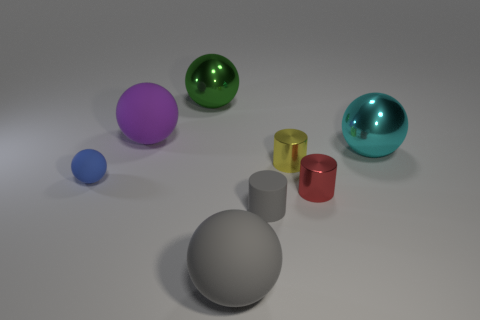How many other objects are there of the same size as the blue rubber object?
Provide a succinct answer. 3. There is a metal cylinder behind the blue rubber sphere; what is its color?
Your response must be concise. Yellow. Are the large sphere right of the red cylinder and the large gray ball made of the same material?
Offer a terse response. No. How many metallic things are to the left of the large cyan sphere and on the right side of the large gray rubber object?
Provide a succinct answer. 2. The large rubber sphere in front of the large matte ball that is on the left side of the big metallic object that is to the left of the big cyan metallic object is what color?
Your answer should be very brief. Gray. How many other things are the same shape as the red thing?
Your answer should be compact. 2. There is a gray thing that is on the right side of the large gray thing; are there any yellow shiny cylinders on the left side of it?
Give a very brief answer. No. How many metal things are tiny red cubes or big objects?
Give a very brief answer. 2. There is a sphere that is both behind the big gray rubber object and in front of the cyan thing; what material is it made of?
Make the answer very short. Rubber. There is a small thing that is on the left side of the big metallic object that is behind the purple matte ball; are there any big balls that are on the left side of it?
Provide a succinct answer. No. 